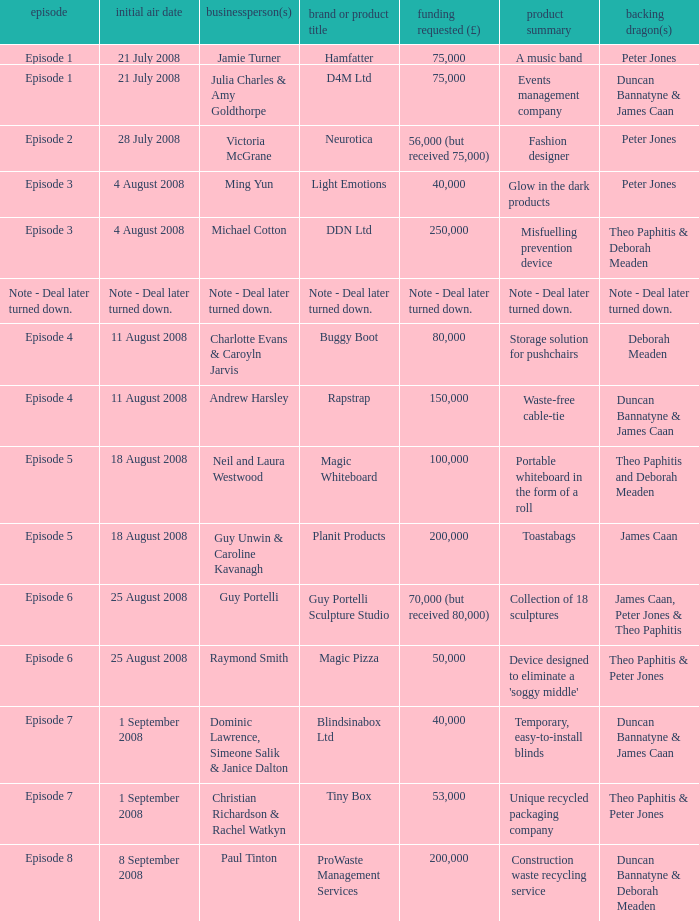How much money did the company Neurotica request? 56,000 (but received 75,000). 